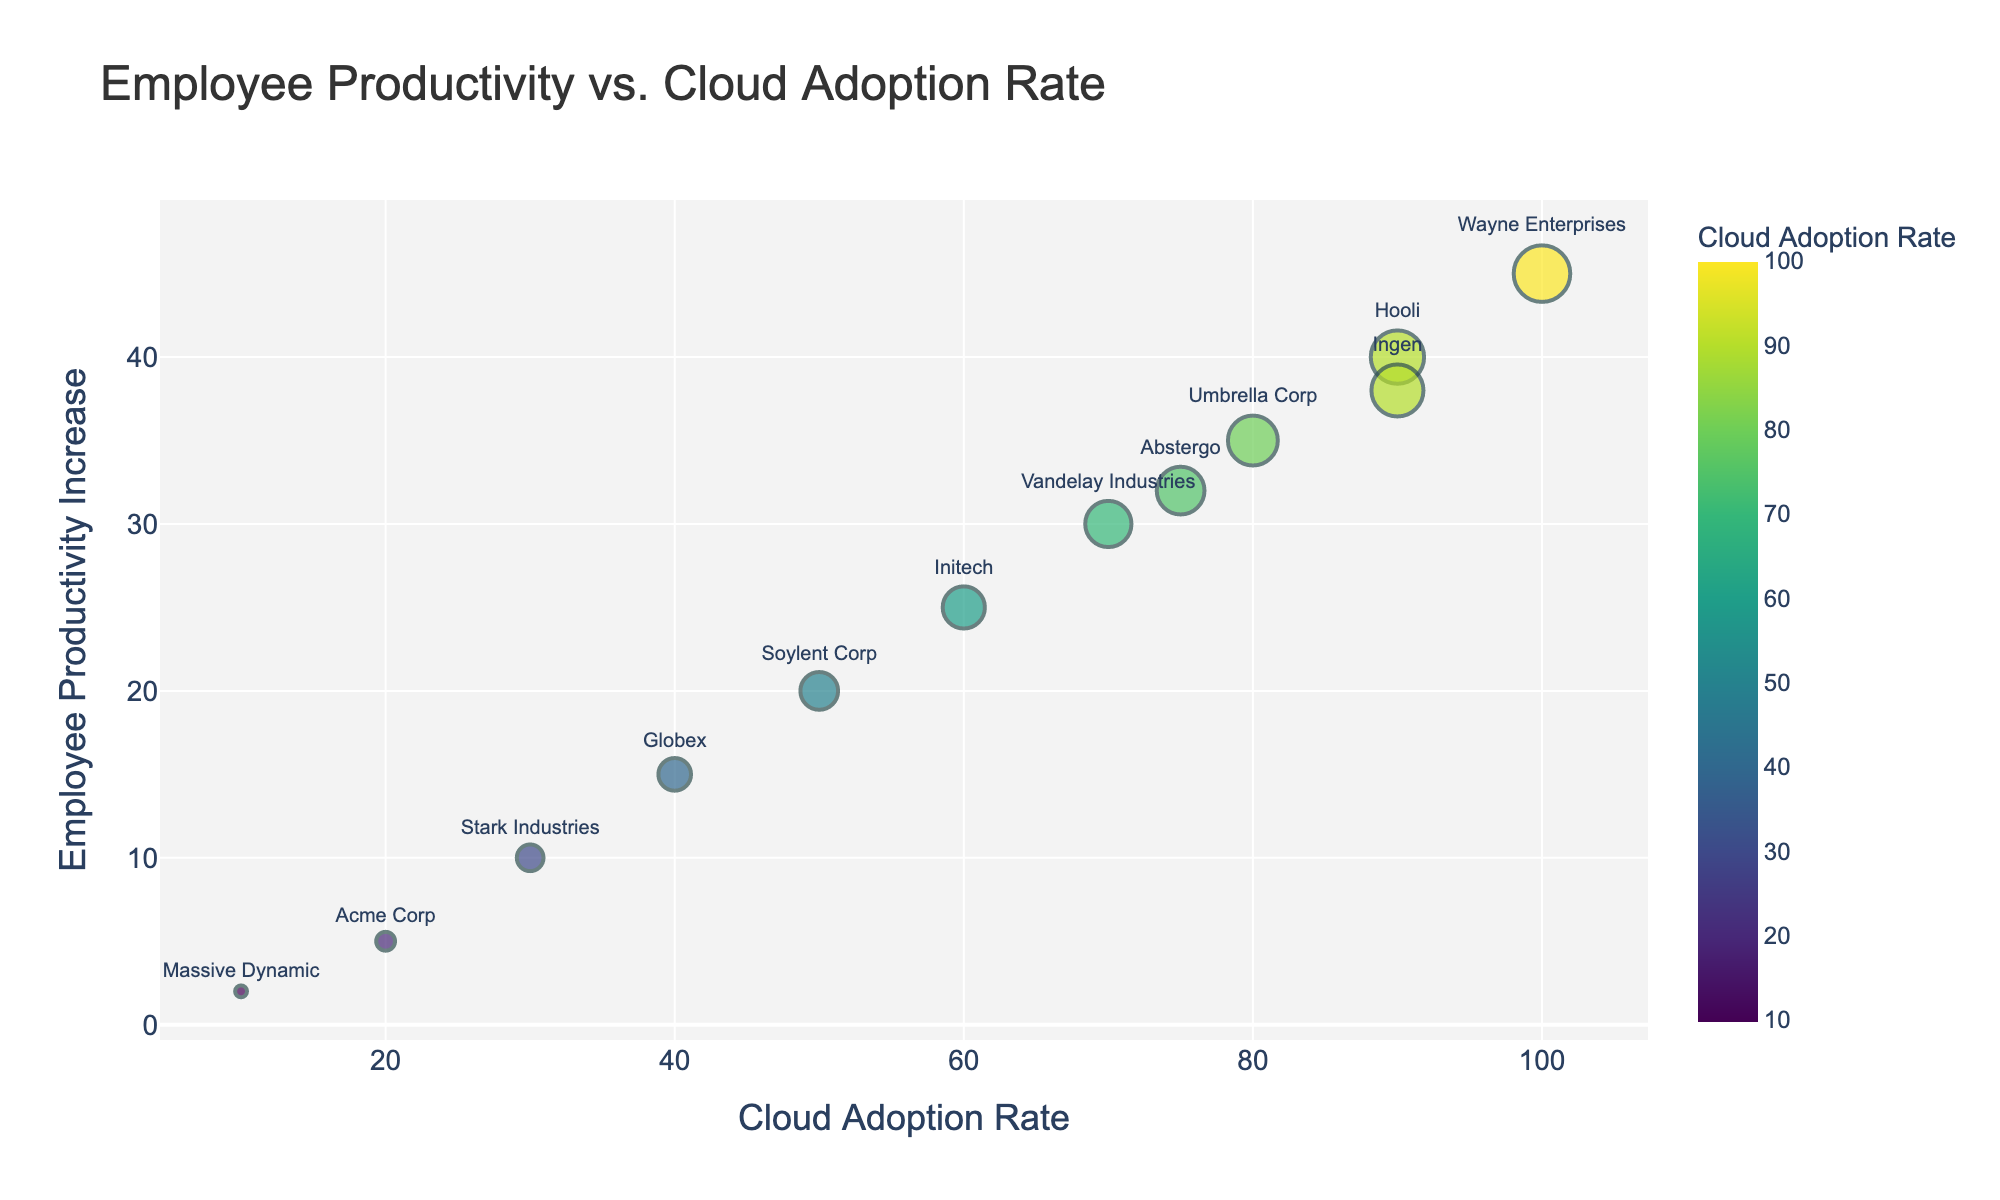What is the title of the scatter plot? The title is typically displayed at the top of the plot. In this case, it states 'Employee Productivity vs. Cloud Adoption Rate', indicating what the plot is about.
Answer: Employee Productivity vs. Cloud Adoption Rate How many companies have a Cloud Adoption Rate of 90% or higher? To find this, identify and count the companies that have a Cloud Adoption Rate of 90% or higher from the dots on the scatter plot.
Answer: 3 Which company has the lowest Employee Productivity Increase? Find the dot positioned at the lowest point on the Y-axis, which represents Employee Productivity Increase. The company associated with this dot is the answer.
Answer: Massive Dynamic Which company has the highest Cloud Adoption Rate? Locate the dot furthest to the right along the X-axis, which represents the highest Cloud Adoption Rate. The company associated with this dot is the answer.
Answer: Wayne Enterprises What is the average Employee Productivity Increase for companies with a Cloud Adoption Rate of 50% or higher? Identify and sum the Employee Productivity Increase percentages for companies with a Cloud Adoption Rate of 50% or more. Then divide by the number of such companies: (25 + 35 + 40 + 30 + 45 + 38 + 32) / 7 = 245 / 7.
Answer: 35 Is there a company with a Cloud Adoption Rate of 30% and an Employee Productivity Increase of 10%? Look for a dot at the coordinate (30, 10). If the company name is displayed there, it is the answer.
Answer: Stark Industries Which two companies have the closest Employee Productivity Increase values, and what are those values? Identify pairs of points closest to each other vertically (Y-axis). Here, "Hooli" and "Ingen" have respective Productivity Increases of 40% and 38%.
Answer: Hooli and Ingen, 40% and 38% What is the range of the Employee Productivity Increase (%)? Identify the maximum and minimum values of Employee Productivity Increase on the Y-axis of the plot and subtract the minimum from the maximum.
Answer: 45 - 2 = 43 How does the company with a Cloud Adoption Rate of 100% perform in terms of Employee Productivity Increase compared to the average performance of all companies? Identify the Productivity Increase of Wayne Enterprises (100% Cloud Adoption). Then, calculate the average Employee Productivity Increase: (5+15+25+35+40+20+30+10+45+2+38+32) / 12 = 297 / 12. Compare the two values.
Answer: Wayne Enterprises (45%) performs better than the average of 24.75% Which company lies closest to the center of the scatter plot, and what does it indicate about its Cloud Adoption Rate and Employee Productivity Increase? The center of the plot can be approximated by the midpoint values of the given ranges. Identify the company nearest to this point. However, note that the exact "center" depends on visual inspection.
Answer: Soylent Corp. (60%, 25%) indicates moderate adoption and productivity increase 